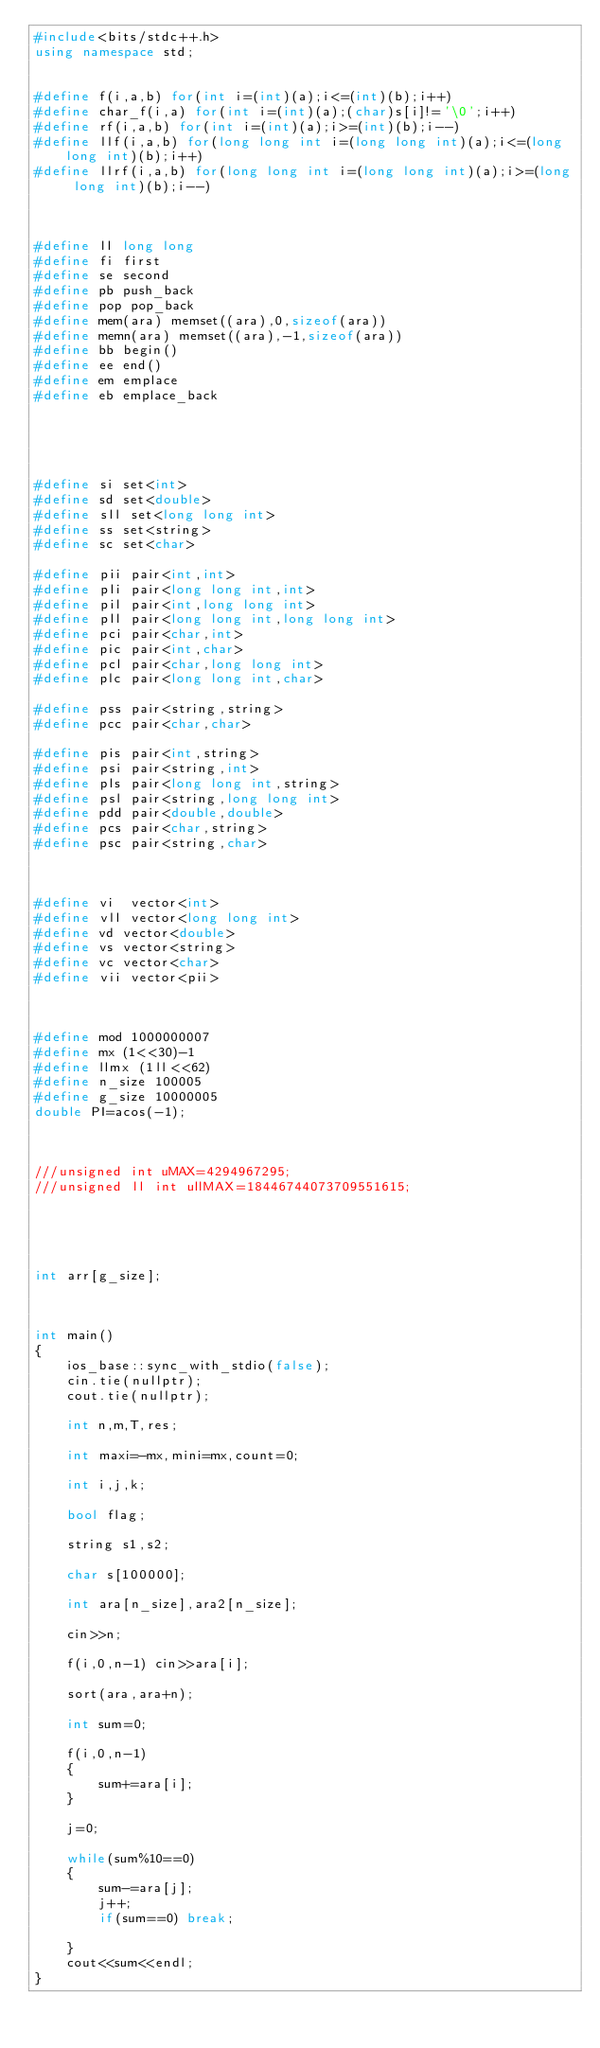<code> <loc_0><loc_0><loc_500><loc_500><_C++_>#include<bits/stdc++.h>
using namespace std;


#define f(i,a,b) for(int i=(int)(a);i<=(int)(b);i++)
#define char_f(i,a) for(int i=(int)(a);(char)s[i]!='\0';i++)
#define rf(i,a,b) for(int i=(int)(a);i>=(int)(b);i--)
#define llf(i,a,b) for(long long int i=(long long int)(a);i<=(long long int)(b);i++)
#define llrf(i,a,b) for(long long int i=(long long int)(a);i>=(long long int)(b);i--)



#define ll long long
#define fi first
#define se second
#define pb push_back
#define pop pop_back
#define mem(ara) memset((ara),0,sizeof(ara))
#define memn(ara) memset((ara),-1,sizeof(ara))
#define bb begin()
#define ee end()
#define em emplace
#define eb emplace_back





#define si set<int>
#define sd set<double>
#define sll set<long long int>
#define ss set<string>
#define sc set<char>

#define pii pair<int,int>
#define pli pair<long long int,int>
#define pil pair<int,long long int>
#define pll pair<long long int,long long int>
#define pci pair<char,int>
#define pic pair<int,char>
#define pcl pair<char,long long int>
#define plc pair<long long int,char>

#define pss pair<string,string>
#define pcc pair<char,char>

#define pis pair<int,string>
#define psi pair<string,int>
#define pls pair<long long int,string>
#define psl pair<string,long long int>
#define pdd pair<double,double>
#define pcs pair<char,string>
#define psc pair<string,char>



#define vi  vector<int>
#define vll vector<long long int>
#define vd vector<double>
#define vs vector<string>
#define vc vector<char>
#define vii vector<pii>



#define mod 1000000007
#define mx (1<<30)-1
#define llmx (1ll<<62)
#define n_size 100005
#define g_size 10000005
double PI=acos(-1);



///unsigned int uMAX=4294967295;
///unsigned ll int ullMAX=18446744073709551615;





int arr[g_size];



int main()
{
	ios_base::sync_with_stdio(false);
	cin.tie(nullptr);
	cout.tie(nullptr);

	int n,m,T,res;

	int maxi=-mx,mini=mx,count=0;

	int i,j,k;

	bool flag;

	string s1,s2;

	char s[100000];

	int ara[n_size],ara2[n_size];

	cin>>n;

	f(i,0,n-1) cin>>ara[i];

	sort(ara,ara+n);

	int sum=0;

	f(i,0,n-1)
	{
	    sum+=ara[i];
	}

	j=0;

	while(sum%10==0)
    {
        sum-=ara[j];
        j++;
        if(sum==0) break;

    }
    cout<<sum<<endl;
}
</code> 